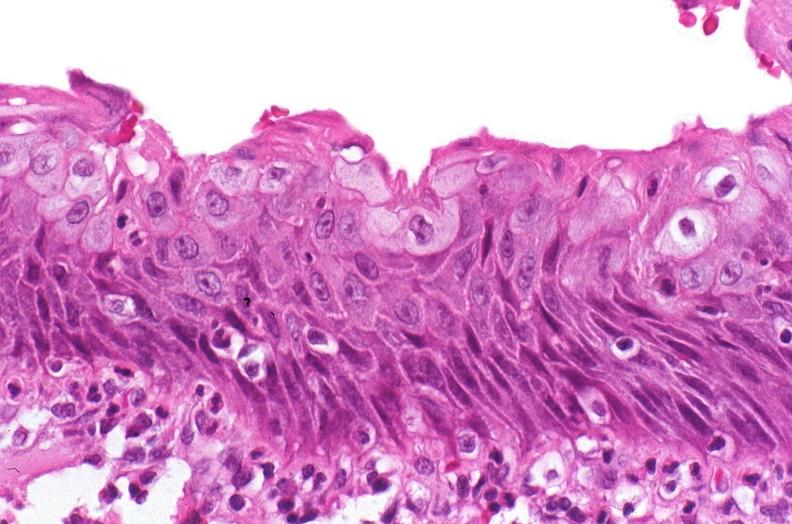why does this image show renal pelvis, squamous metaplasia?
Answer the question using a single word or phrase. Due to chronic urolithiasis 